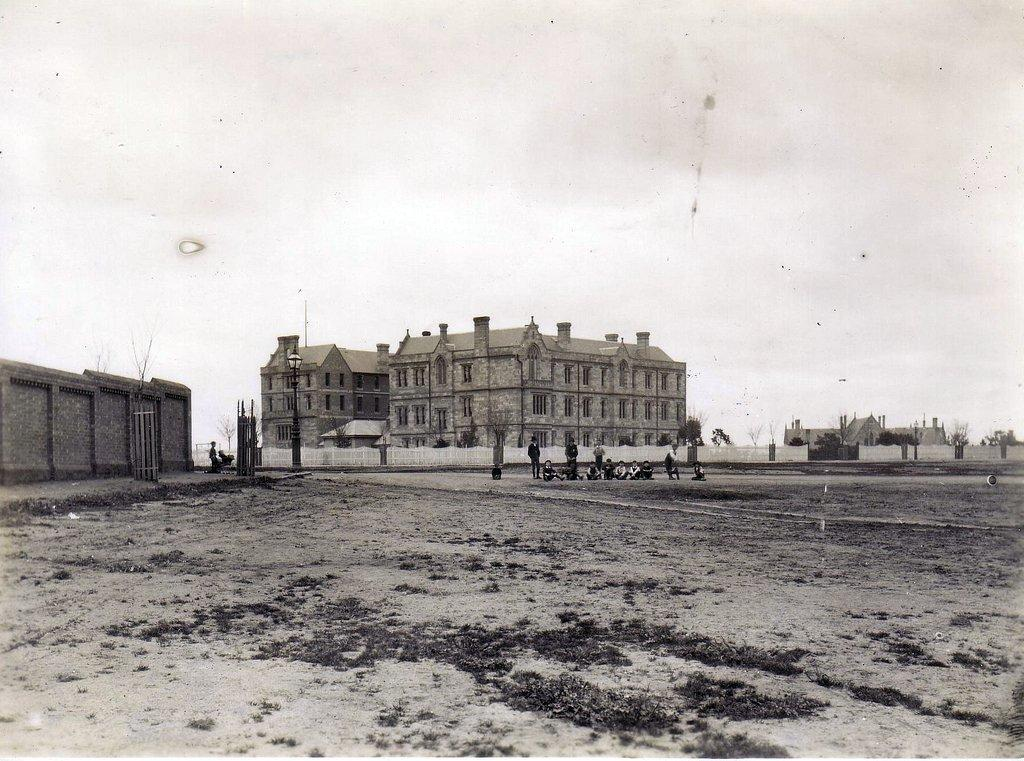What are the people in the image doing? The people in the image are standing on the road. What can be seen in the background of the image? There are houses, trees, and poles in the background. Is there a river flowing through the scene in the image? There is no river present in the image. What type of carriage can be seen parked near the people? There is no carriage present in the image. 